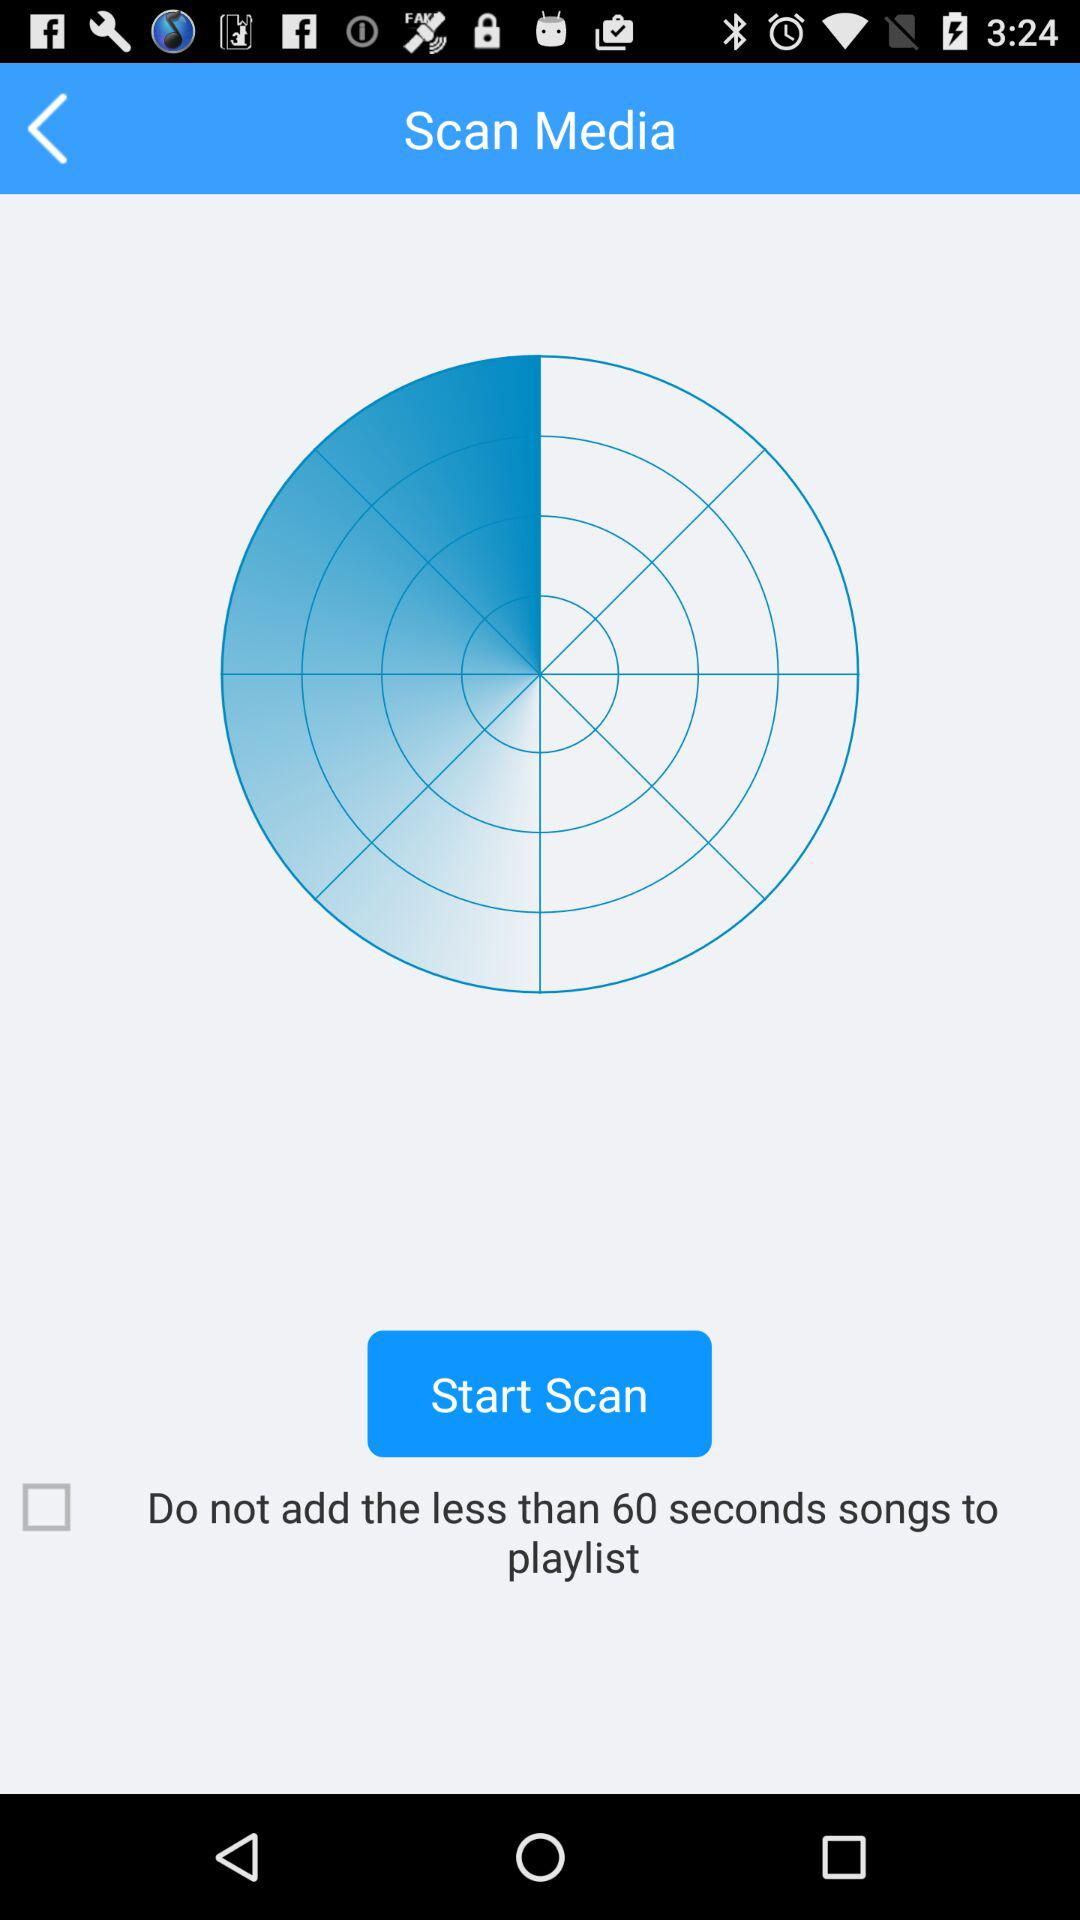How much time duration songs should not be added? The songs that are less than 60 seconds should not be added. 